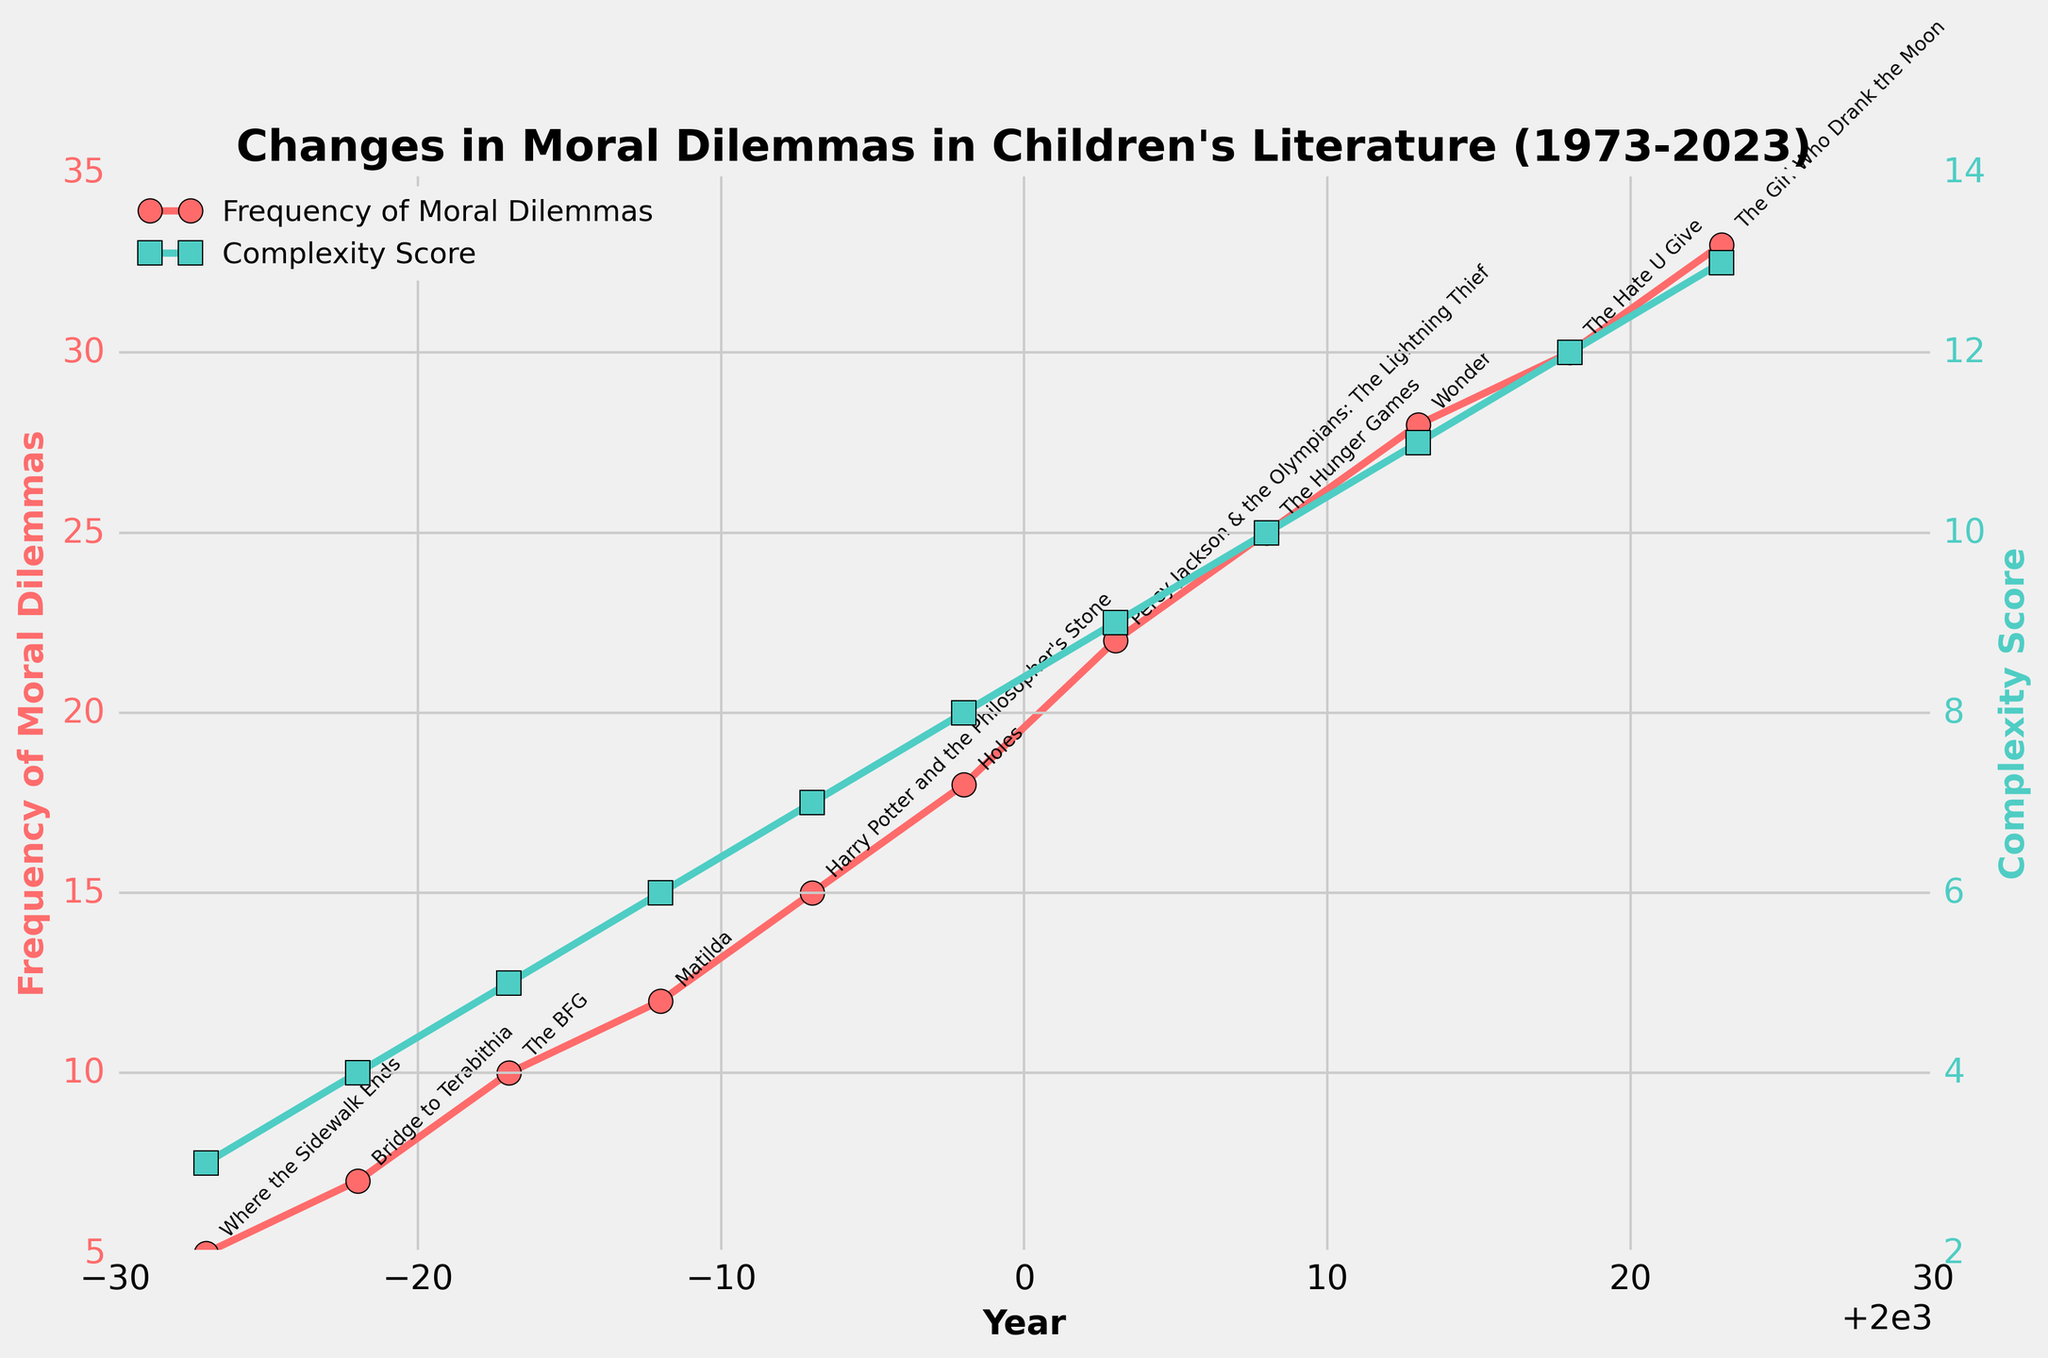What is the title of the figure? The title of the figure is located at the top and provides an overview of what the plot represents. By looking at the top of the figure, we can see that the title is "Changes in Moral Dilemmas in Children's Literature (1973-2023)"
Answer: Changes in Moral Dilemmas in Children's Literature (1973-2023) Which color represents the Frequency of Moral Dilemmas? The color for the Frequency of Moral Dilemmas plot line can be identified by looking at the line with circular markers and its legend on the left side. The line is red with circular markers.
Answer: Red How many data points are depicted in the figure? By counting the number of distinct year points on the x-axis or the number of markers on either line, we can determine the number of data points. There are 11 markers showing the data points from 1973 to 2023.
Answer: 11 What is the Complexity Score in the year 2003? The Complexity Score for a specific year can be found by identifying the square marker on the greenish line corresponding to the year 2003. The marker is positioned at a y-value of 9.
Answer: 9 Which book title is associated with the highest Complexity Score? The highest Complexity Score can be determined by finding the highest point on the Complexity Score (green) line. The corresponding annotation gives the book title as "The Girl Who Drank the Moon," which corresponds to the year 2023.
Answer: The Girl Who Drank the Moon What is the difference in Frequency of Moral Dilemmas between the years 1973 and 2023? To find the difference, identify the Frequency of Moral Dilemmas for 1973 and for 2023 from the red line. Subtract 5 (1973) from 33 (2023). The difference is 33 - 5 = 28.
Answer: 28 By how much did the Complexity Score increase from 1983 to 1988? Determine the values of Complexity Score for the years 1983 and 1988 from the green line (5 for 1983 and 6 for 1988). Subtract 5 from 6 to find the increase. 6 - 5 = 1.
Answer: 1 Which year saw the largest jump in Frequency of Moral Dilemmas compared to the previous year? Observe the red line and compare the difference between consecutive points visually. The largest jump is between 1993 and 1998 (15 to 18), a difference of 3.
Answer: 1993 to 1998 What are the values of both Frequency of Moral Dilemmas and Complexity Score in the year 1998? Trace both the red line (Frequency) and the green line (Complexity) for the year 1998. The Frequency of Moral Dilemmas is 18, and the Complexity Score is 8.
Answer: 18 and 8 